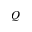Convert formula to latex. <formula><loc_0><loc_0><loc_500><loc_500>Q</formula> 